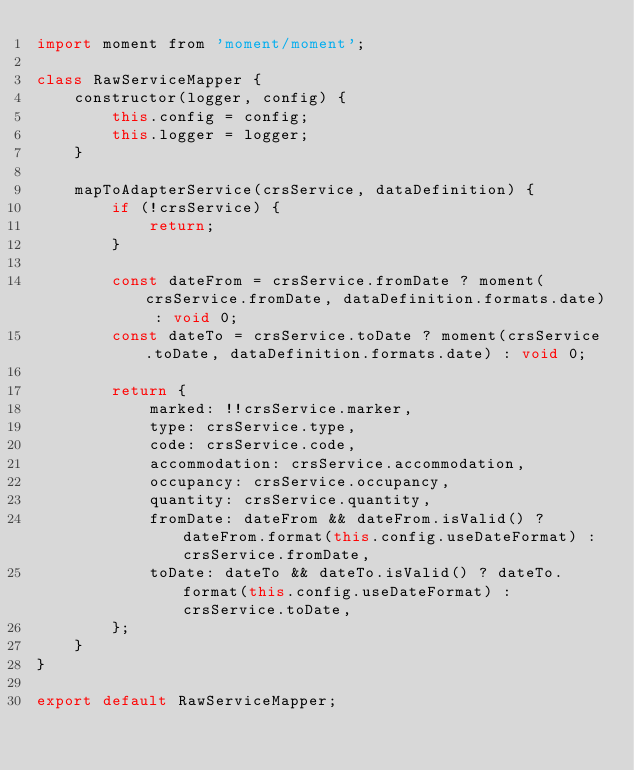<code> <loc_0><loc_0><loc_500><loc_500><_JavaScript_>import moment from 'moment/moment';

class RawServiceMapper {
    constructor(logger, config) {
        this.config = config;
        this.logger = logger;
    }

    mapToAdapterService(crsService, dataDefinition) {
        if (!crsService) {
            return;
        }

        const dateFrom = crsService.fromDate ? moment(crsService.fromDate, dataDefinition.formats.date) : void 0;
        const dateTo = crsService.toDate ? moment(crsService.toDate, dataDefinition.formats.date) : void 0;

        return {
            marked: !!crsService.marker,
            type: crsService.type,
            code: crsService.code,
            accommodation: crsService.accommodation,
            occupancy: crsService.occupancy,
            quantity: crsService.quantity,
            fromDate: dateFrom && dateFrom.isValid() ? dateFrom.format(this.config.useDateFormat) : crsService.fromDate,
            toDate: dateTo && dateTo.isValid() ? dateTo.format(this.config.useDateFormat) : crsService.toDate,
        };
    }
}

export default RawServiceMapper;
</code> 